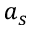Convert formula to latex. <formula><loc_0><loc_0><loc_500><loc_500>a _ { s }</formula> 